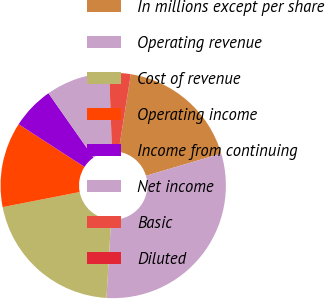Convert chart. <chart><loc_0><loc_0><loc_500><loc_500><pie_chart><fcel>In millions except per share<fcel>Operating revenue<fcel>Cost of revenue<fcel>Operating income<fcel>Income from continuing<fcel>Net income<fcel>Basic<fcel>Diluted<nl><fcel>17.92%<fcel>30.53%<fcel>20.97%<fcel>12.22%<fcel>6.12%<fcel>9.17%<fcel>3.06%<fcel>0.01%<nl></chart> 